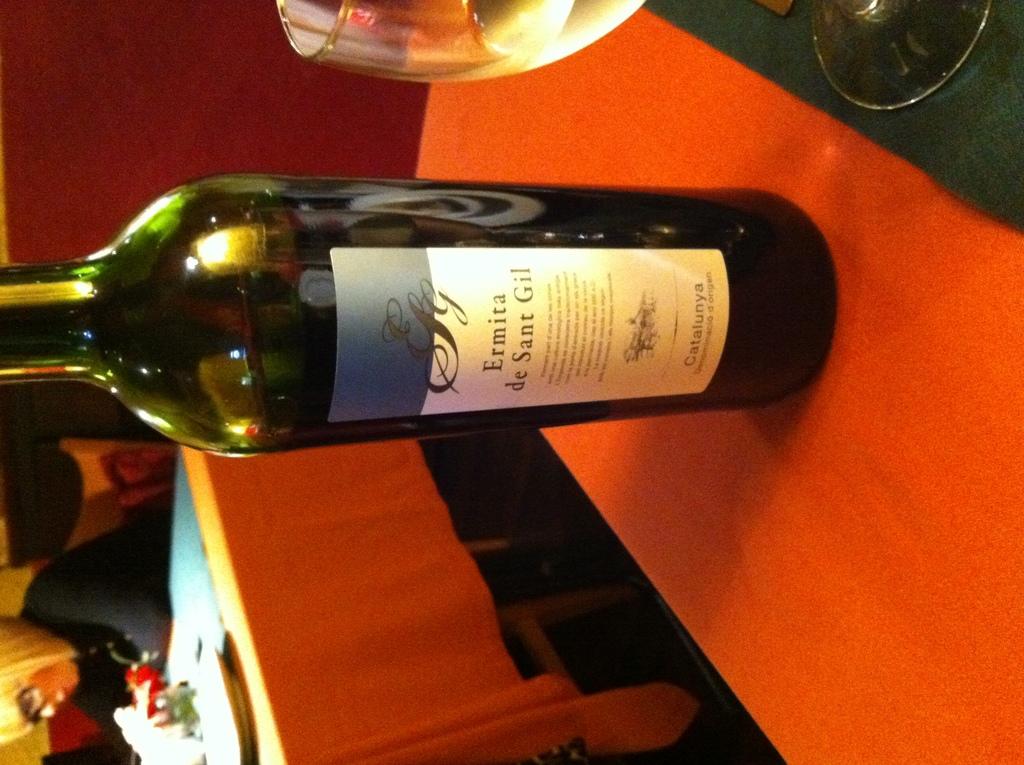Where does this wine originate?
Make the answer very short. Catalunya. What brand is this wine?
Your response must be concise. Ermita de sant gil. 